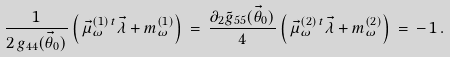Convert formula to latex. <formula><loc_0><loc_0><loc_500><loc_500>\frac { 1 } { 2 \, g _ { 4 4 } ( \vec { \theta } _ { 0 } ) } \left ( \, \vec { \mu } ^ { ( 1 ) \, t } _ { \omega } \vec { \lambda } + m ^ { ( 1 ) } _ { \omega } \right ) \, = \, \frac { \partial _ { 2 } \tilde { g } _ { 5 5 } ( \vec { \theta } _ { 0 } ) } { 4 } \left ( \, \vec { \mu } ^ { ( 2 ) \, t } _ { \omega } \vec { \lambda } + m ^ { ( 2 ) } _ { \omega } \right ) \, = \, - \, 1 \, .</formula> 